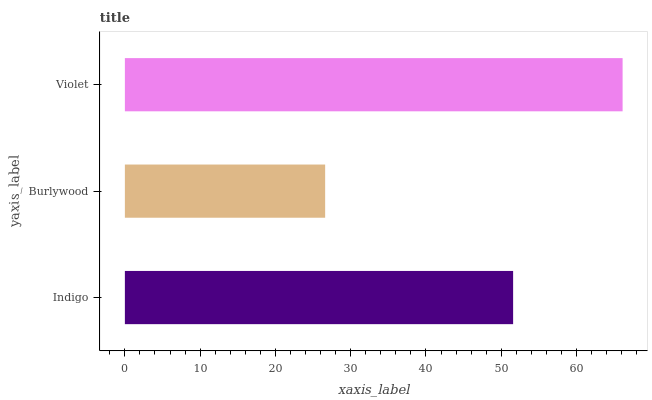Is Burlywood the minimum?
Answer yes or no. Yes. Is Violet the maximum?
Answer yes or no. Yes. Is Violet the minimum?
Answer yes or no. No. Is Burlywood the maximum?
Answer yes or no. No. Is Violet greater than Burlywood?
Answer yes or no. Yes. Is Burlywood less than Violet?
Answer yes or no. Yes. Is Burlywood greater than Violet?
Answer yes or no. No. Is Violet less than Burlywood?
Answer yes or no. No. Is Indigo the high median?
Answer yes or no. Yes. Is Indigo the low median?
Answer yes or no. Yes. Is Violet the high median?
Answer yes or no. No. Is Violet the low median?
Answer yes or no. No. 